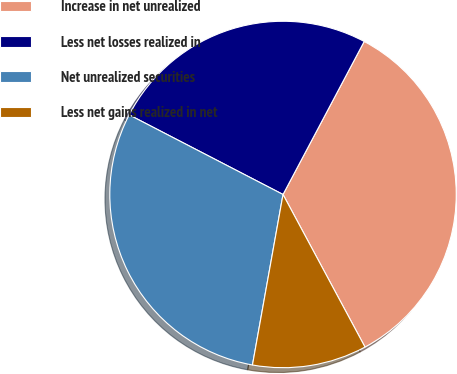Convert chart. <chart><loc_0><loc_0><loc_500><loc_500><pie_chart><fcel>Increase in net unrealized<fcel>Less net losses realized in<fcel>Net unrealized securities<fcel>Less net gains realized in net<nl><fcel>34.39%<fcel>25.16%<fcel>29.78%<fcel>10.67%<nl></chart> 